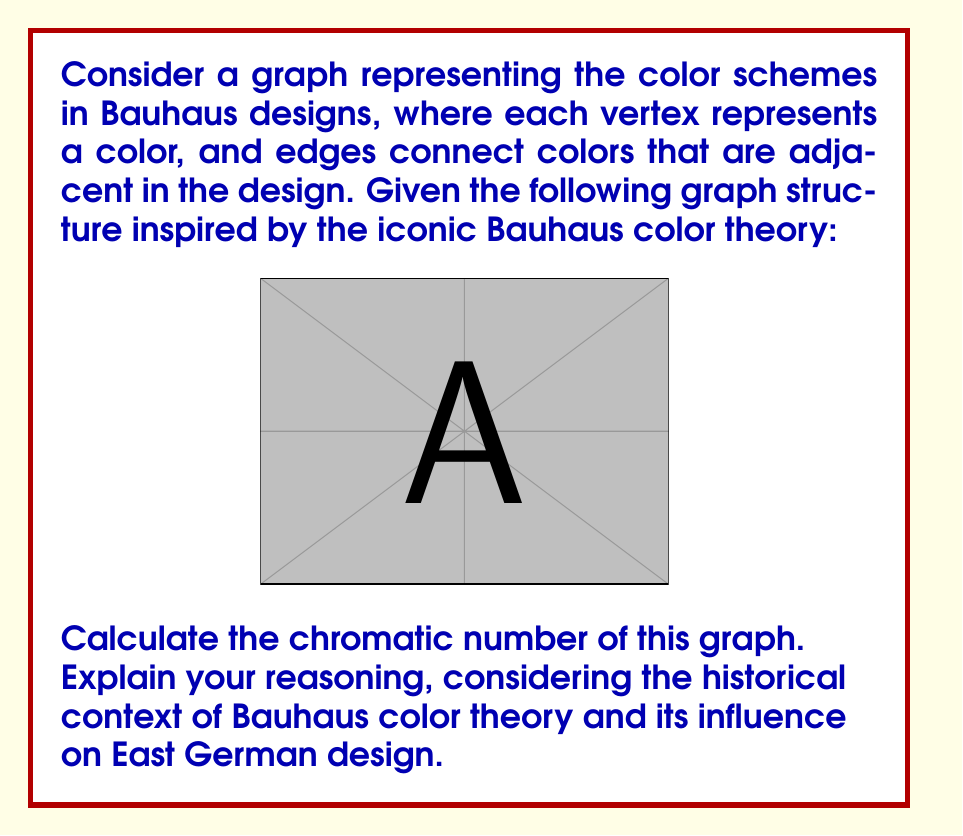Could you help me with this problem? To solve this problem, we need to consider both the mathematical properties of the graph and the historical context of Bauhaus color theory.

1. Graph analysis:
   The given graph is a complete graph with 7 vertices, denoted as $K_7$. In a complete graph, every vertex is connected to every other vertex.

2. Chromatic number definition:
   The chromatic number of a graph, denoted as $\chi(G)$, is the minimum number of colors needed to color the vertices of the graph such that no two adjacent vertices have the same color.

3. Chromatic number of a complete graph:
   For a complete graph $K_n$ with $n$ vertices, the chromatic number is always equal to $n$. This is because each vertex must have a different color from all others, as it is adjacent to every other vertex.

4. Bauhaus color theory context:
   The Bauhaus school, founded in 1919 in Weimar, Germany, had a significant influence on design, including color theory. Johannes Itten, a Bauhaus master, developed a color wheel with 12 hues. However, the graph in this problem has 7 vertices, which could represent the 7 main colors often used in Bauhaus designs: red, blue, yellow (primary colors), green, orange, purple (secondary colors), and a neutral color like white or black.

5. East German design influence:
   The Bauhaus style, including its color theory, had a lasting impact on East German design, particularly in architecture and industrial design. The rational and functional approach of Bauhaus, combined with its distinctive use of color, continued to influence East German aesthetics even after the school's closure in 1933.

6. Calculating the chromatic number:
   Given that we have a complete graph $K_7$, the chromatic number is:

   $$\chi(G) = 7$$

   This means we need 7 distinct colors to properly color the graph, which aligns with the 7 main colors often used in Bauhaus designs.
Answer: The chromatic number of the given graph is $\chi(G) = 7$. 